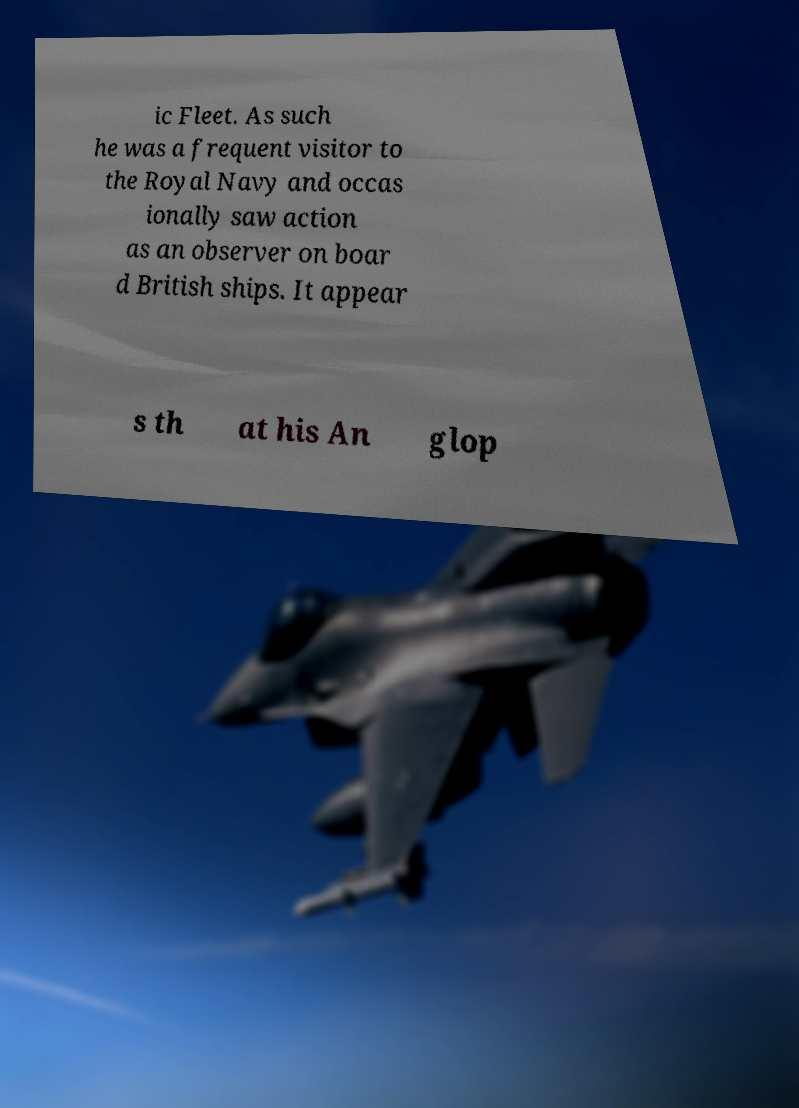Can you read and provide the text displayed in the image?This photo seems to have some interesting text. Can you extract and type it out for me? ic Fleet. As such he was a frequent visitor to the Royal Navy and occas ionally saw action as an observer on boar d British ships. It appear s th at his An glop 